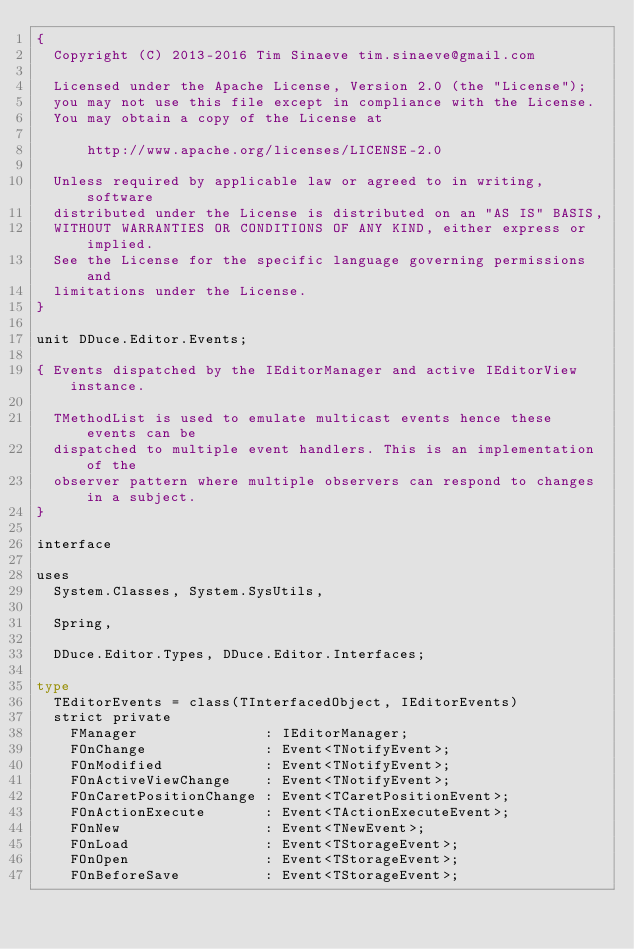<code> <loc_0><loc_0><loc_500><loc_500><_Pascal_>{
  Copyright (C) 2013-2016 Tim Sinaeve tim.sinaeve@gmail.com

  Licensed under the Apache License, Version 2.0 (the "License");
  you may not use this file except in compliance with the License.
  You may obtain a copy of the License at

      http://www.apache.org/licenses/LICENSE-2.0

  Unless required by applicable law or agreed to in writing, software
  distributed under the License is distributed on an "AS IS" BASIS,
  WITHOUT WARRANTIES OR CONDITIONS OF ANY KIND, either express or implied.
  See the License for the specific language governing permissions and
  limitations under the License.
}

unit DDuce.Editor.Events;

{ Events dispatched by the IEditorManager and active IEditorView instance.

  TMethodList is used to emulate multicast events hence these events can be
  dispatched to multiple event handlers. This is an implementation of the
  observer pattern where multiple observers can respond to changes in a subject.
}

interface

uses
  System.Classes, System.SysUtils,

  Spring,

  DDuce.Editor.Types, DDuce.Editor.Interfaces;

type
  TEditorEvents = class(TInterfacedObject, IEditorEvents)
  strict private
    FManager               : IEditorManager;
    FOnChange              : Event<TNotifyEvent>;
    FOnModified            : Event<TNotifyEvent>;
    FOnActiveViewChange    : Event<TNotifyEvent>;
    FOnCaretPositionChange : Event<TCaretPositionEvent>;
    FOnActionExecute       : Event<TActionExecuteEvent>;
    FOnNew                 : Event<TNewEvent>;
    FOnLoad                : Event<TStorageEvent>;
    FOnOpen                : Event<TStorageEvent>;
    FOnBeforeSave          : Event<TStorageEvent>;</code> 